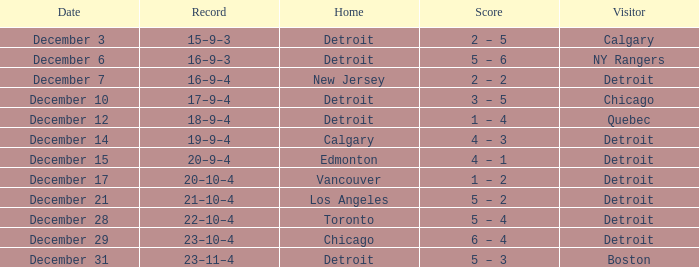Who is the visitor on december 3? Calgary. Parse the full table. {'header': ['Date', 'Record', 'Home', 'Score', 'Visitor'], 'rows': [['December 3', '15–9–3', 'Detroit', '2 – 5', 'Calgary'], ['December 6', '16–9–3', 'Detroit', '5 – 6', 'NY Rangers'], ['December 7', '16–9–4', 'New Jersey', '2 – 2', 'Detroit'], ['December 10', '17–9–4', 'Detroit', '3 – 5', 'Chicago'], ['December 12', '18–9–4', 'Detroit', '1 – 4', 'Quebec'], ['December 14', '19–9–4', 'Calgary', '4 – 3', 'Detroit'], ['December 15', '20–9–4', 'Edmonton', '4 – 1', 'Detroit'], ['December 17', '20–10–4', 'Vancouver', '1 – 2', 'Detroit'], ['December 21', '21–10–4', 'Los Angeles', '5 – 2', 'Detroit'], ['December 28', '22–10–4', 'Toronto', '5 – 4', 'Detroit'], ['December 29', '23–10–4', 'Chicago', '6 – 4', 'Detroit'], ['December 31', '23–11–4', 'Detroit', '5 – 3', 'Boston']]} 